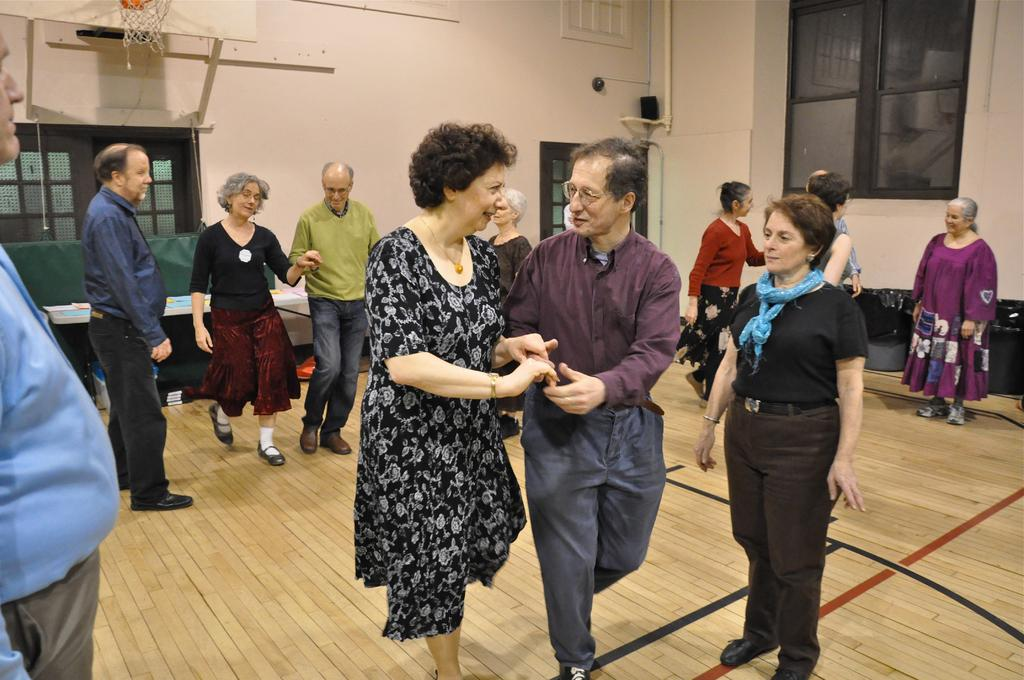Who or what can be seen in the image? There are people in the image. What can be seen in the background of the image? There is a hoop, a window, and other objects in the background of the image. Can you describe the rods in the image? Yes, there are rods in the image. What is at the bottom of the image? There is a floor at the bottom of the image. What level of competition is the team participating in, as seen in the image? There is no team or competition present in the image, so it is not possible to determine the level of competition. 